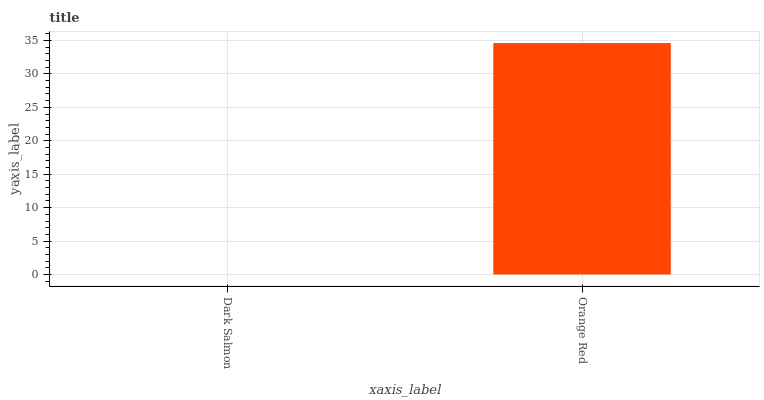Is Orange Red the minimum?
Answer yes or no. No. Is Orange Red greater than Dark Salmon?
Answer yes or no. Yes. Is Dark Salmon less than Orange Red?
Answer yes or no. Yes. Is Dark Salmon greater than Orange Red?
Answer yes or no. No. Is Orange Red less than Dark Salmon?
Answer yes or no. No. Is Orange Red the high median?
Answer yes or no. Yes. Is Dark Salmon the low median?
Answer yes or no. Yes. Is Dark Salmon the high median?
Answer yes or no. No. Is Orange Red the low median?
Answer yes or no. No. 